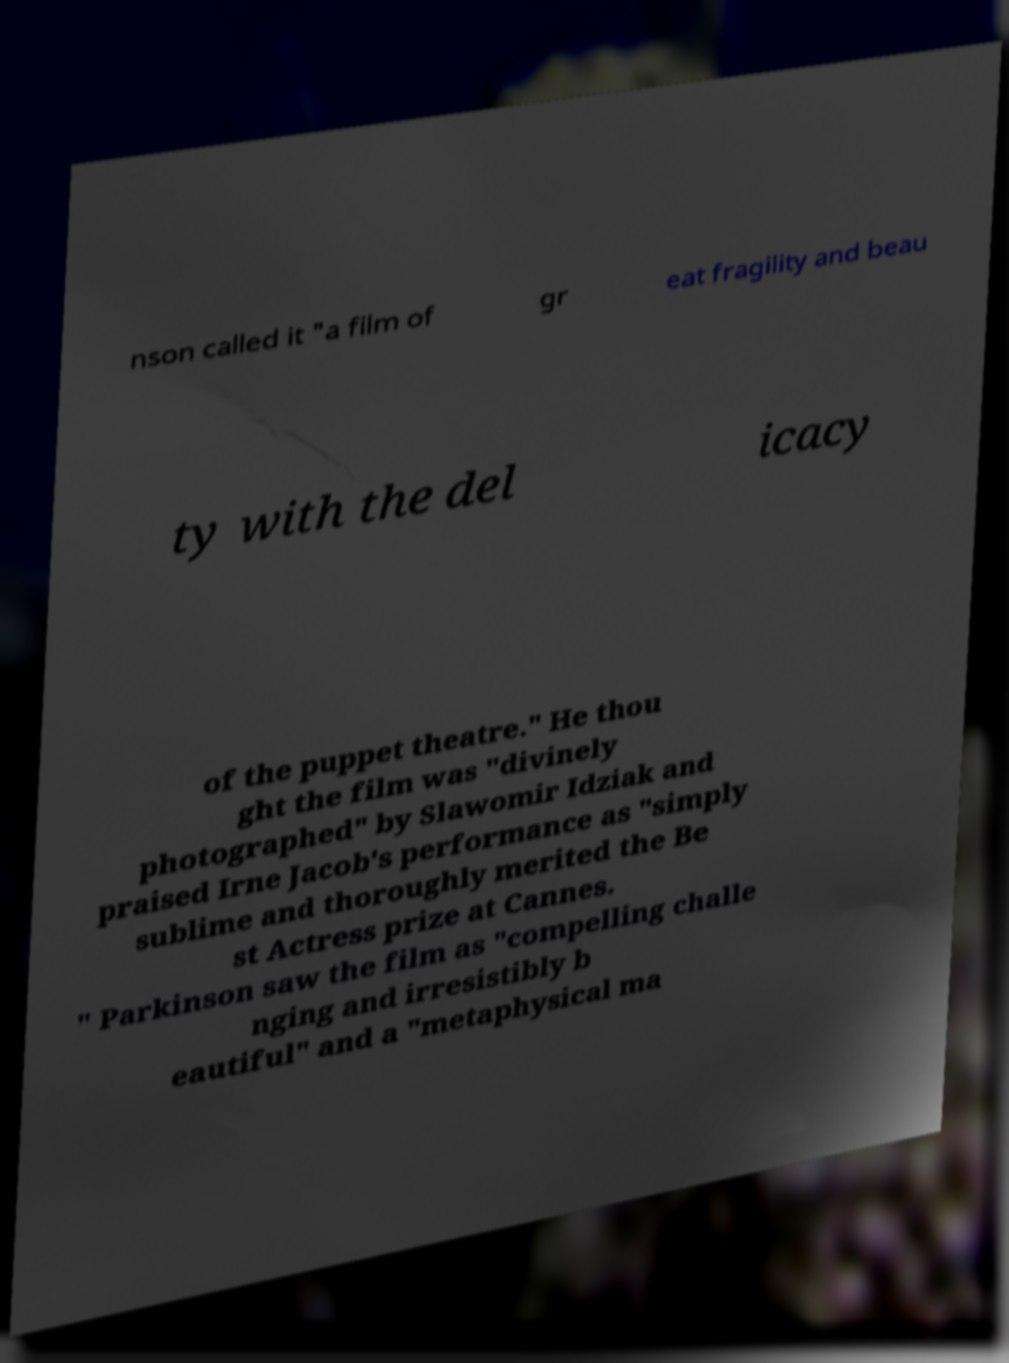Could you assist in decoding the text presented in this image and type it out clearly? nson called it "a film of gr eat fragility and beau ty with the del icacy of the puppet theatre." He thou ght the film was "divinely photographed" by Slawomir Idziak and praised Irne Jacob's performance as "simply sublime and thoroughly merited the Be st Actress prize at Cannes. " Parkinson saw the film as "compelling challe nging and irresistibly b eautiful" and a "metaphysical ma 